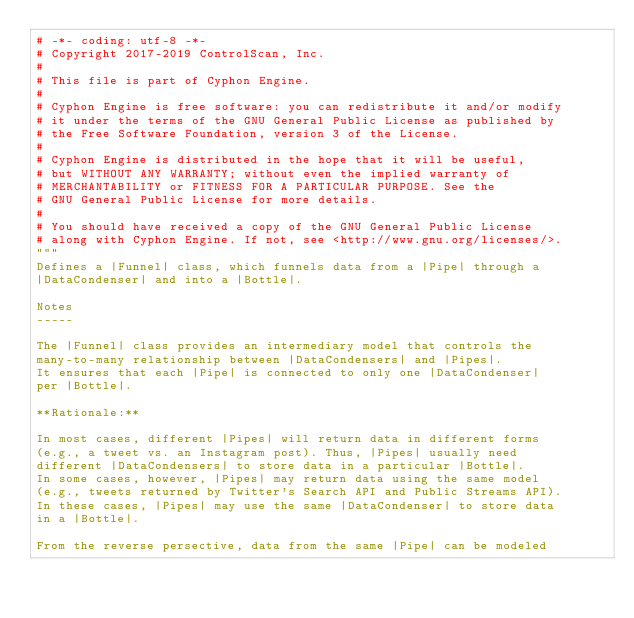<code> <loc_0><loc_0><loc_500><loc_500><_Python_># -*- coding: utf-8 -*-
# Copyright 2017-2019 ControlScan, Inc.
#
# This file is part of Cyphon Engine.
#
# Cyphon Engine is free software: you can redistribute it and/or modify
# it under the terms of the GNU General Public License as published by
# the Free Software Foundation, version 3 of the License.
#
# Cyphon Engine is distributed in the hope that it will be useful,
# but WITHOUT ANY WARRANTY; without even the implied warranty of
# MERCHANTABILITY or FITNESS FOR A PARTICULAR PURPOSE. See the
# GNU General Public License for more details.
#
# You should have received a copy of the GNU General Public License
# along with Cyphon Engine. If not, see <http://www.gnu.org/licenses/>.
"""
Defines a |Funnel| class, which funnels data from a |Pipe| through a
|DataCondenser| and into a |Bottle|.

Notes
-----

The |Funnel| class provides an intermediary model that controls the
many-to-many relationship between |DataCondensers| and |Pipes|.
It ensures that each |Pipe| is connected to only one |DataCondenser|
per |Bottle|.

**Rationale:**

In most cases, different |Pipes| will return data in different forms
(e.g., a tweet vs. an Instagram post). Thus, |Pipes| usually need
different |DataCondensers| to store data in a particular |Bottle|.
In some cases, however, |Pipes| may return data using the same model
(e.g., tweets returned by Twitter's Search API and Public Streams API).
In these cases, |Pipes| may use the same |DataCondenser| to store data
in a |Bottle|.

From the reverse persective, data from the same |Pipe| can be modeled</code> 